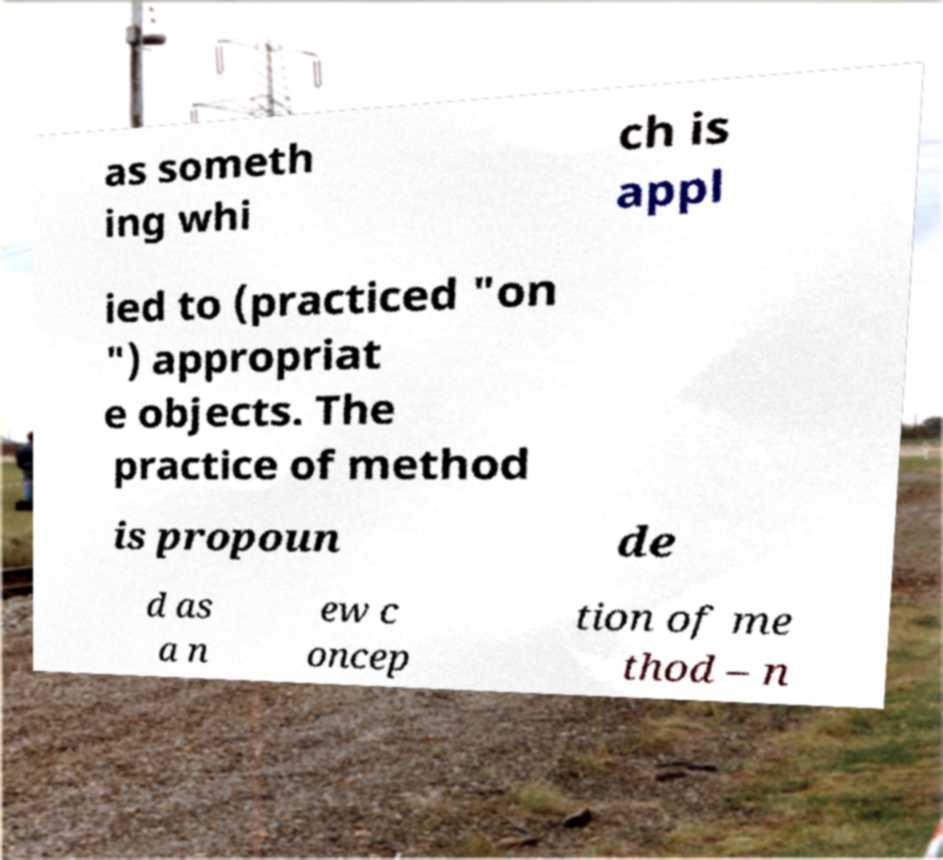Could you assist in decoding the text presented in this image and type it out clearly? as someth ing whi ch is appl ied to (practiced "on ") appropriat e objects. The practice of method is propoun de d as a n ew c oncep tion of me thod – n 